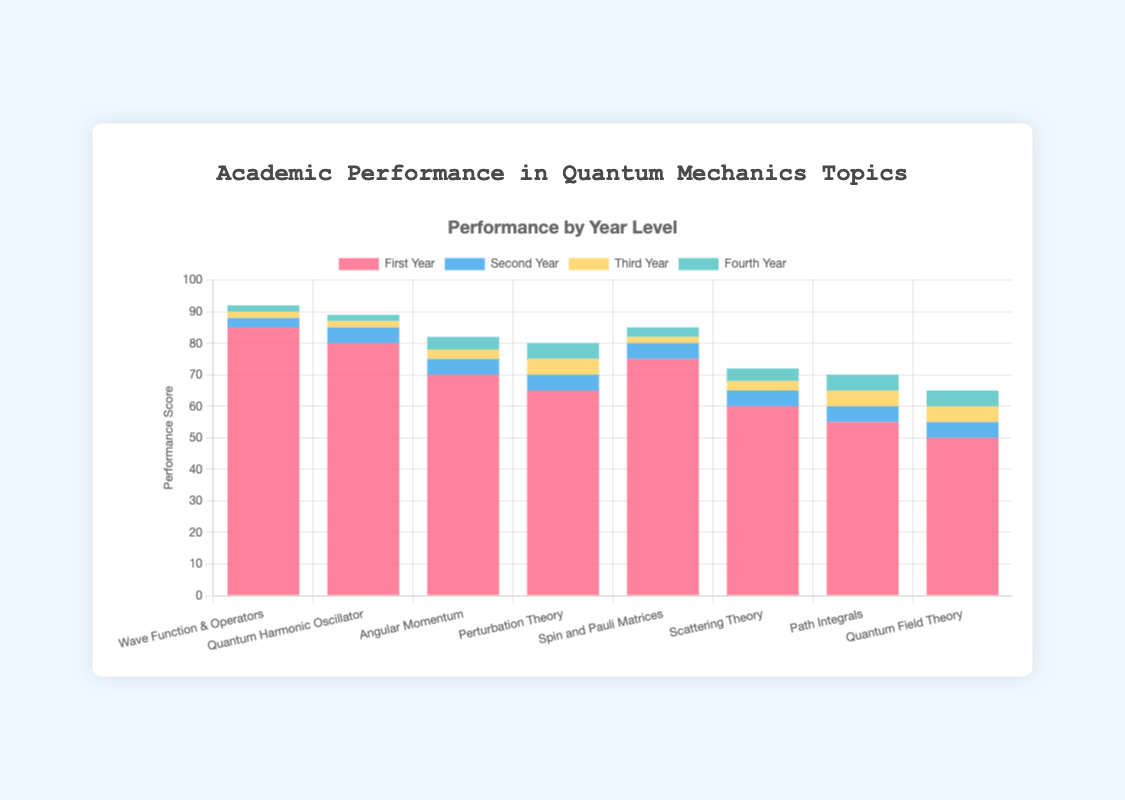What is the performance score for "Wave Function & Operators" in the first year? Look at the height of the bar corresponding to "Wave Function & Operators" in red (First Year). The score is directly labeled.
Answer: 85 Which quantum mechanics topic showed the most improvement from the first year to the fourth year? Calculate the difference between the fourth-year and first-year scores for each topic. Path Integrals improved from 55 to 70, a difference of 15, which is the highest increase among all topics.
Answer: Path Integrals Which year level consistently shows the lowest performance across most topics? Visually compare the heights of the bars for all year levels across topics. The blue bars (Fourth Year) appear to be significantly higher in most cases, while the red bars (First Year) tend to be the lowest.
Answer: First Year What is the total performance score for "Spin and Pauli Matrices" across all years? Sum the performance scores for "Spin and Pauli Matrices" across all years: 75 (First Year) + 80 (Second Year) + 82 (Third Year) + 85 (Fourth Year). The total score is 322.
Answer: 322 How does the performance in "Quantum Harmonic Oscillator" compare between third and fourth years? Look at the respective bar heights of yellow (Third Year) and green (Fourth Year) for "Quantum Harmonic Oscillator". The third year has a score of 87, and the fourth year has a score of 89, making the latter higher.
Answer: Fourth Year is higher Calculate the average performance score for "Perturbation Theory" across all year levels. Sum the performance scores for "Perturbation Theory" across all years: 65 (First Year) + 70 (Second Year) + 75 (Third Year) + 80 (Fourth Year). The total is 290. Divide 290 by 4, resulting in an average score of 72.5.
Answer: 72.5 Which topic has the smallest difference in performance between the second and fourth years? Calculate the difference between the second year and fourth year for each topic. For "Wave Function & Operators", it's 92-88=4; for "Quantum Harmonic Oscillator", it's 89-85=4; for "Angular Momentum", it's 82-75=7, etc. The smallest difference, which is 4, is found in "Wave Function & Operators" and "Quantum Harmonic Oscillator".
Answer: Wave Function & Operators and Quantum Harmonic Oscillator Which topic has the lowest performance score in the fourth year and what is the score? Observe the green bars representing the fourth year for each topic. The "Quantum Field Theory" bar is the lowest at 65.
Answer: Quantum Field Theory with 65 